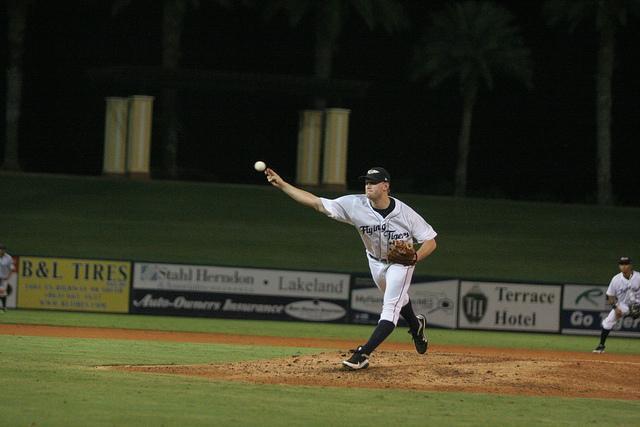How many different advertisements can you spot?
Give a very brief answer. 5. How many people can be seen?
Give a very brief answer. 2. 